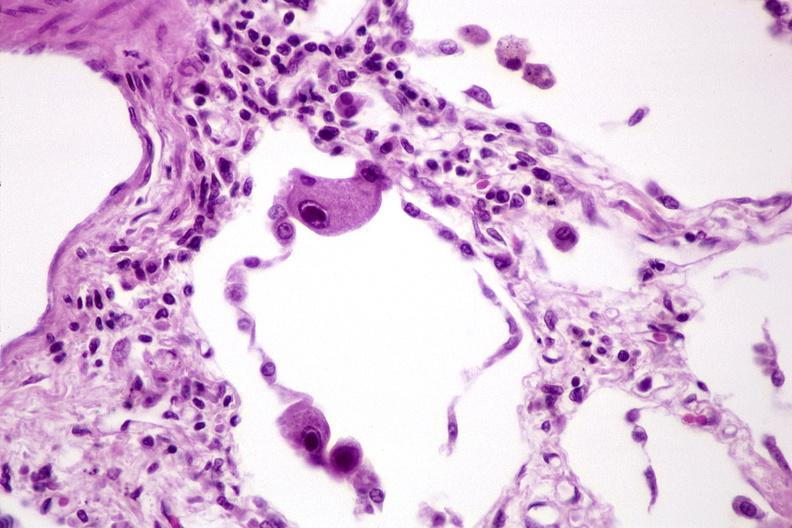does this image show lung, cyomegalovirus pneumonia?
Answer the question using a single word or phrase. Yes 